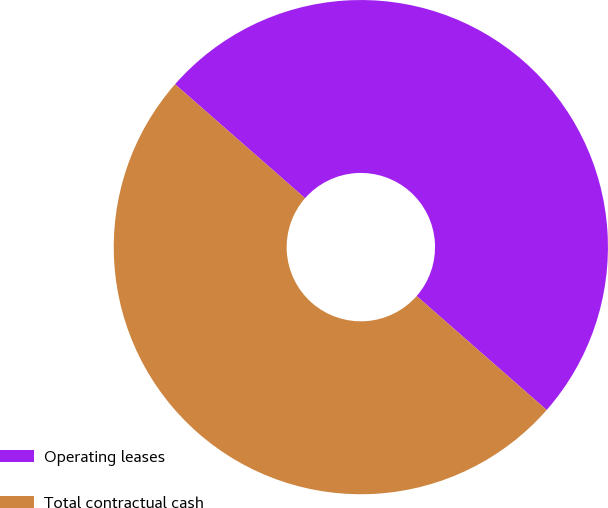Convert chart. <chart><loc_0><loc_0><loc_500><loc_500><pie_chart><fcel>Operating leases<fcel>Total contractual cash<nl><fcel>50.0%<fcel>50.0%<nl></chart> 